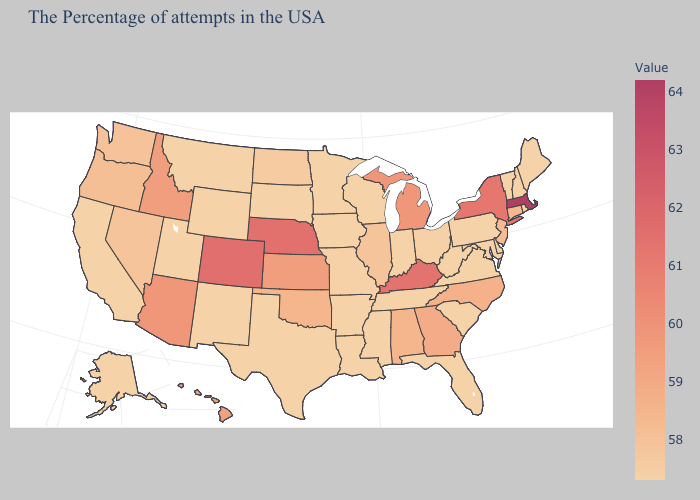Does the map have missing data?
Answer briefly. No. Which states have the lowest value in the South?
Give a very brief answer. Delaware, Maryland, Virginia, South Carolina, West Virginia, Florida, Tennessee, Mississippi, Louisiana, Arkansas, Texas. Is the legend a continuous bar?
Be succinct. Yes. Does Maryland have a higher value than Massachusetts?
Quick response, please. No. 